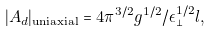Convert formula to latex. <formula><loc_0><loc_0><loc_500><loc_500>| A _ { d } | _ { \text {uniaxial} } = 4 \pi ^ { 3 / 2 } g ^ { 1 / 2 } / \epsilon _ { \perp } ^ { 1 / 2 } l ,</formula> 